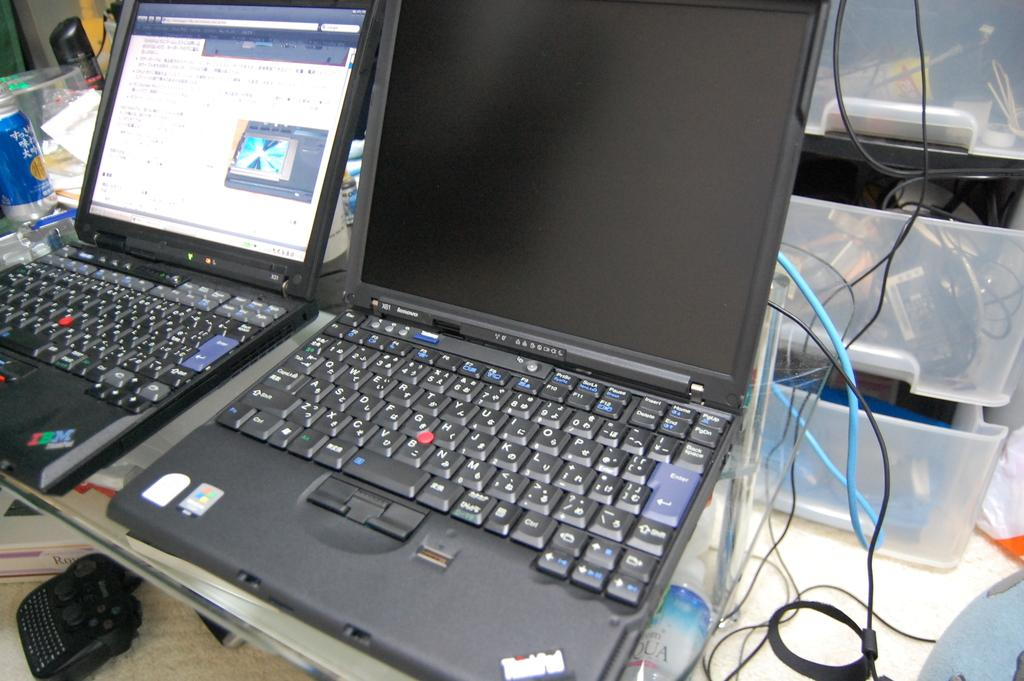<image>
Present a compact description of the photo's key features. Two open laptops, the left one of which has the letters IBM on the bottom right 